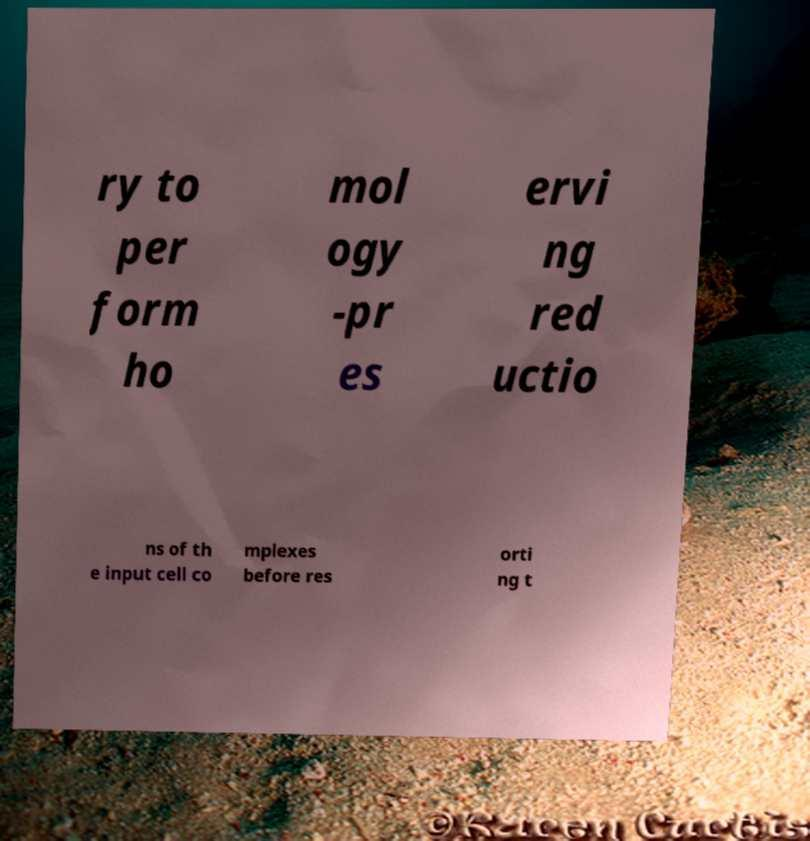For documentation purposes, I need the text within this image transcribed. Could you provide that? ry to per form ho mol ogy -pr es ervi ng red uctio ns of th e input cell co mplexes before res orti ng t 